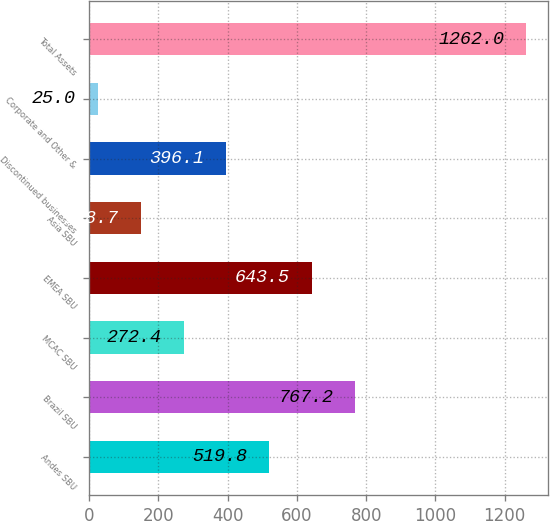Convert chart to OTSL. <chart><loc_0><loc_0><loc_500><loc_500><bar_chart><fcel>Andes SBU<fcel>Brazil SBU<fcel>MCAC SBU<fcel>EMEA SBU<fcel>Asia SBU<fcel>Discontinued businesses<fcel>Corporate and Other &<fcel>Total Assets<nl><fcel>519.8<fcel>767.2<fcel>272.4<fcel>643.5<fcel>148.7<fcel>396.1<fcel>25<fcel>1262<nl></chart> 